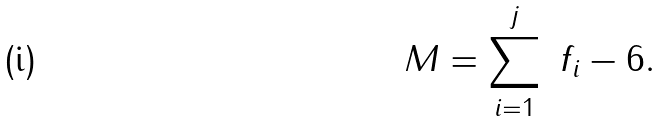Convert formula to latex. <formula><loc_0><loc_0><loc_500><loc_500>M = \sum _ { i = 1 } ^ { j } \ f _ { i } - 6 .</formula> 